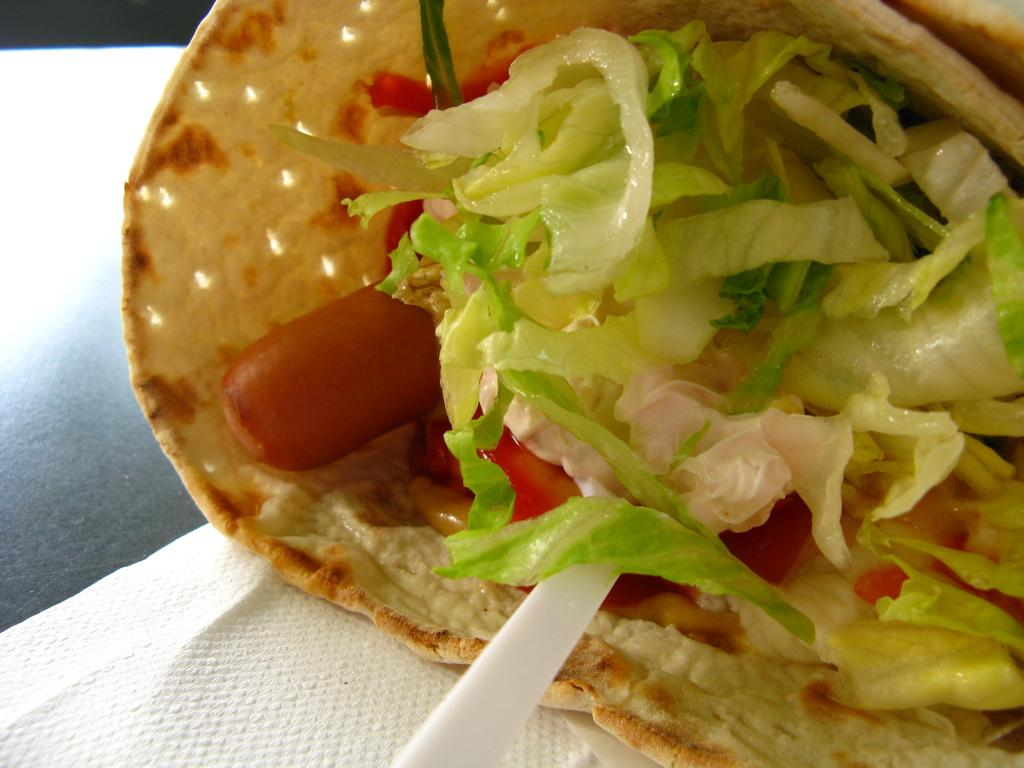What type of food can be seen in the image? There is food in the image, but the specific type is not mentioned in the facts. What utensil is present in the image? There is a spoon in the image. What item is used for cleaning or wiping in the image? There is a tissue in the image. Where is the tissue located in the image? The tissue is placed on a table. Are there any family members visible in the image? There is no mention of family members in the facts provided, so we cannot determine if they are present in the image. Can you see the person who placed the tissue on the table in the image? The facts provided do not mention any people in the image, so we cannot determine if someone is visible. Are there any snails crawling on the table in the image? There is no mention of snails in the facts provided, so we cannot determine if they are present in the image. 